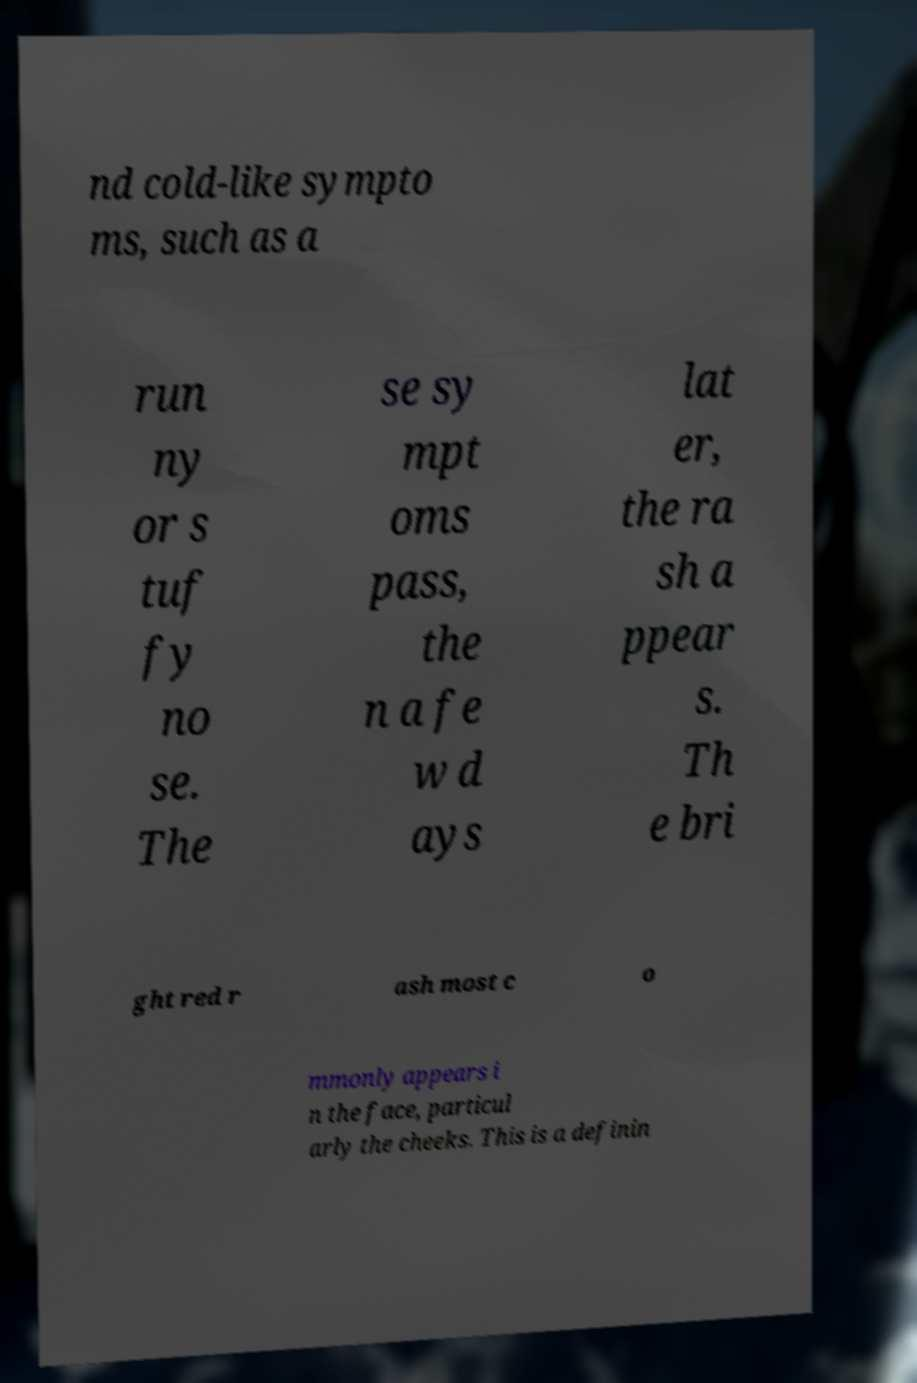Could you extract and type out the text from this image? nd cold-like sympto ms, such as a run ny or s tuf fy no se. The se sy mpt oms pass, the n a fe w d ays lat er, the ra sh a ppear s. Th e bri ght red r ash most c o mmonly appears i n the face, particul arly the cheeks. This is a definin 